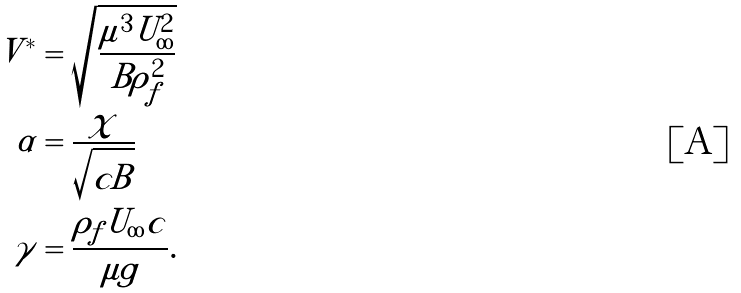<formula> <loc_0><loc_0><loc_500><loc_500>V ^ { * } & = \sqrt { \frac { \mu ^ { 3 } U _ { \infty } ^ { 2 } } { B \rho _ { f } ^ { 2 } } } \\ \alpha & = \frac { \chi } { \sqrt { c B } } \\ \gamma & = \frac { \rho _ { f } U _ { \infty } c } { \mu g } .</formula> 